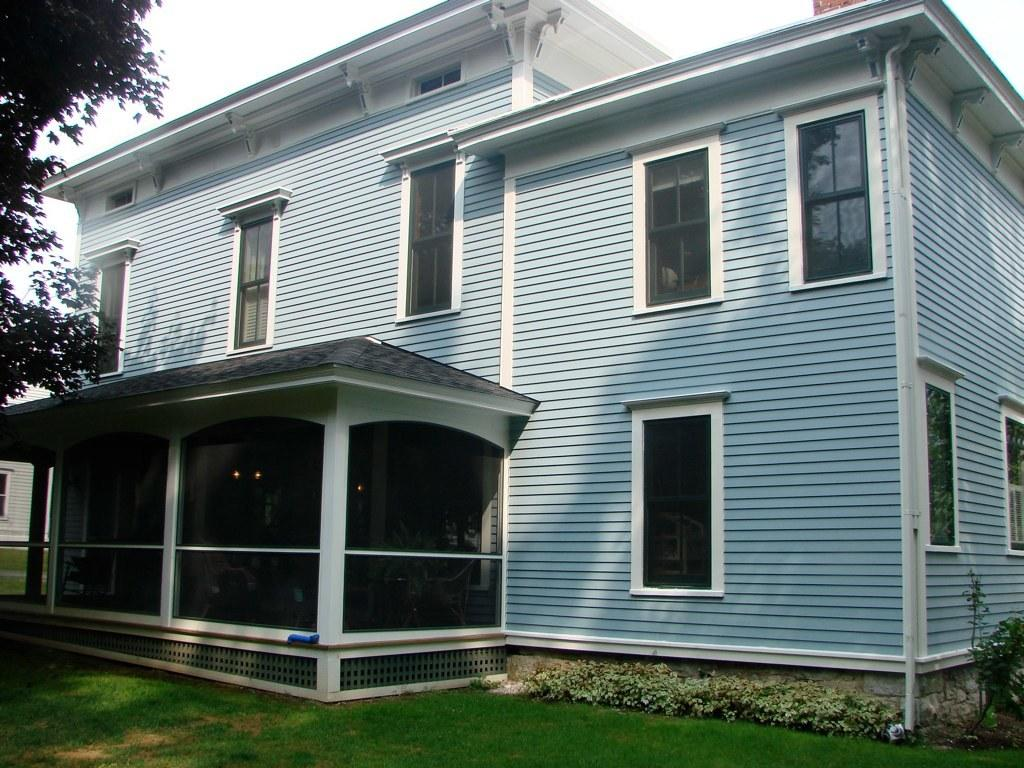What type of structure is present in the image? There is a house in the image. What feature can be seen on the house? There are glass windows on the house. What type of vegetation is visible in the image? There are trees visible in the image. What is the color of the sky in the image? The sky appears to be white in color. How many boots are hanging from the trees in the image? There are no boots hanging from the trees in the image; only trees are present. Can you tell me how many cats are sitting on the roof of the house in the image? There are no cats visible in the image; only the house, glass windows, trees, and sky are present. 